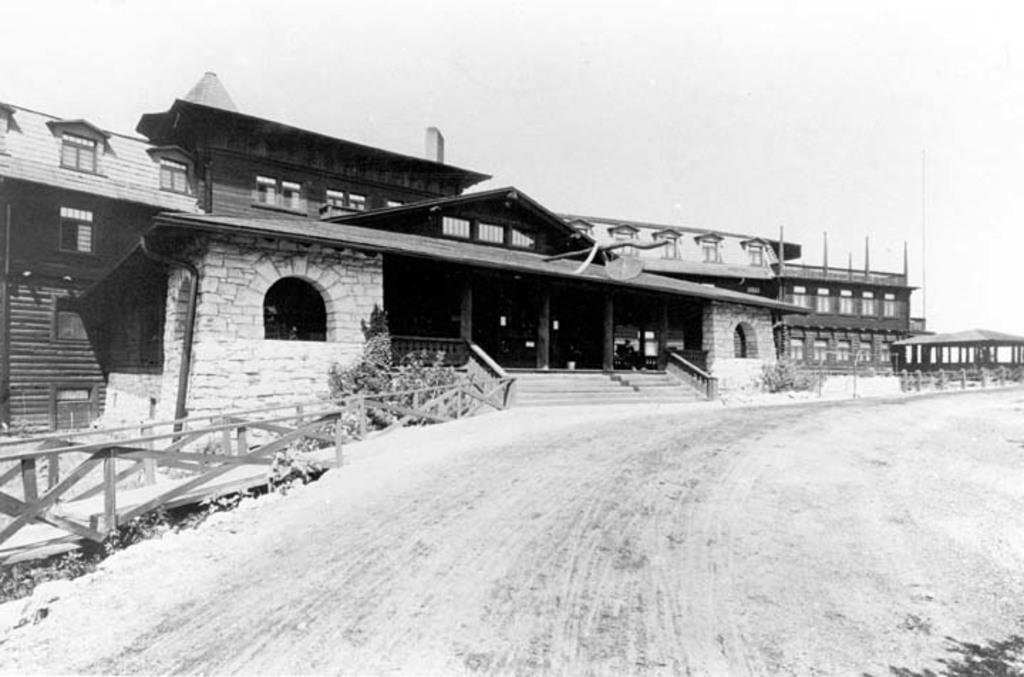What is the color scheme of the image? The image is black and white. What type of structures can be seen in the image? There are buildings in the image. What is the purpose of the road in the image? The road in the image is likely for transportation. What architectural feature is present in the image? There are steps in the image. What type of vegetation is visible in the image? There are plants in the image. What part of the natural environment is visible in the image? The sky is visible in the image. How many deer can be seen grazing on the plants in the image? There are no deer present in the image; it features buildings, a road, steps, plants, and the sky. 